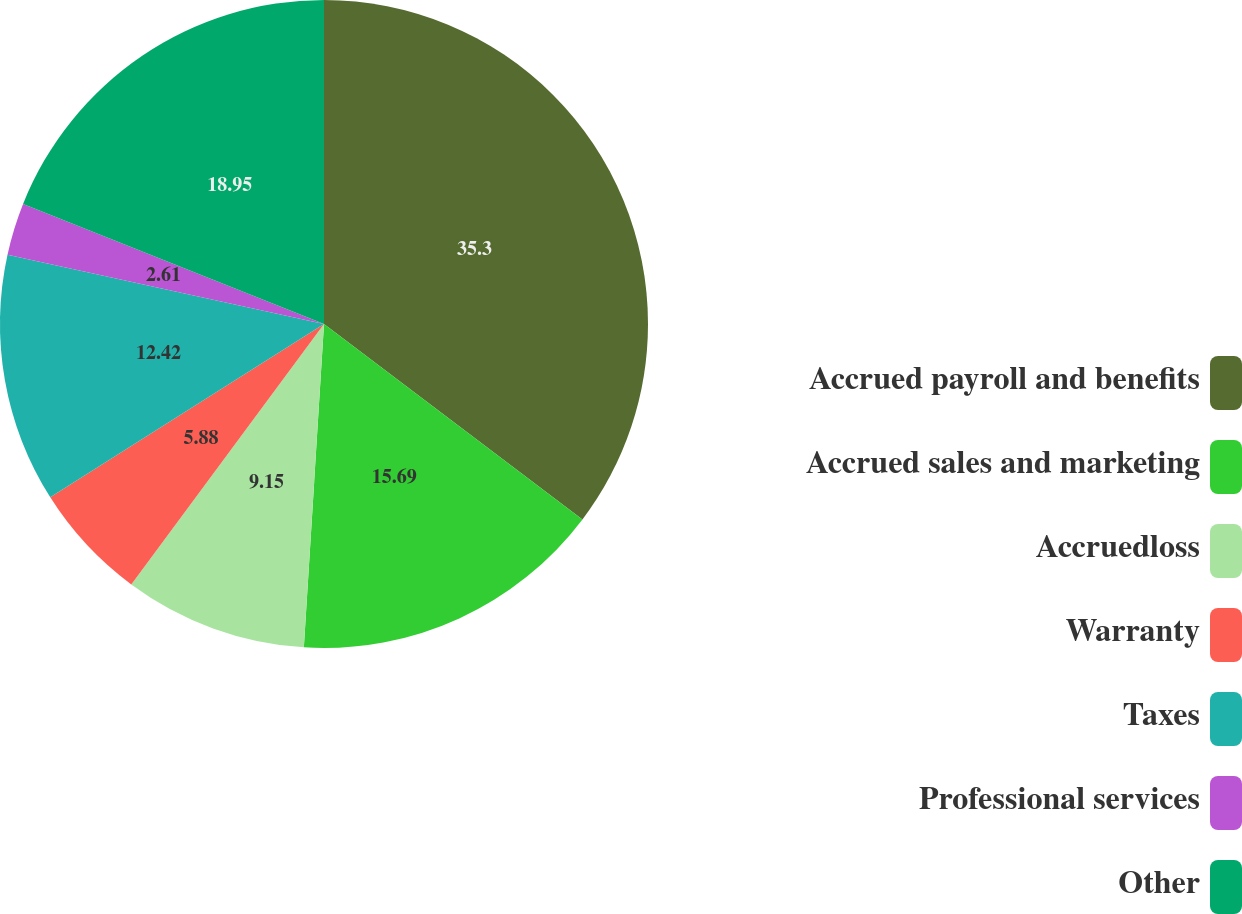<chart> <loc_0><loc_0><loc_500><loc_500><pie_chart><fcel>Accrued payroll and benefits<fcel>Accrued sales and marketing<fcel>Accruedloss<fcel>Warranty<fcel>Taxes<fcel>Professional services<fcel>Other<nl><fcel>35.31%<fcel>15.69%<fcel>9.15%<fcel>5.88%<fcel>12.42%<fcel>2.61%<fcel>18.96%<nl></chart> 